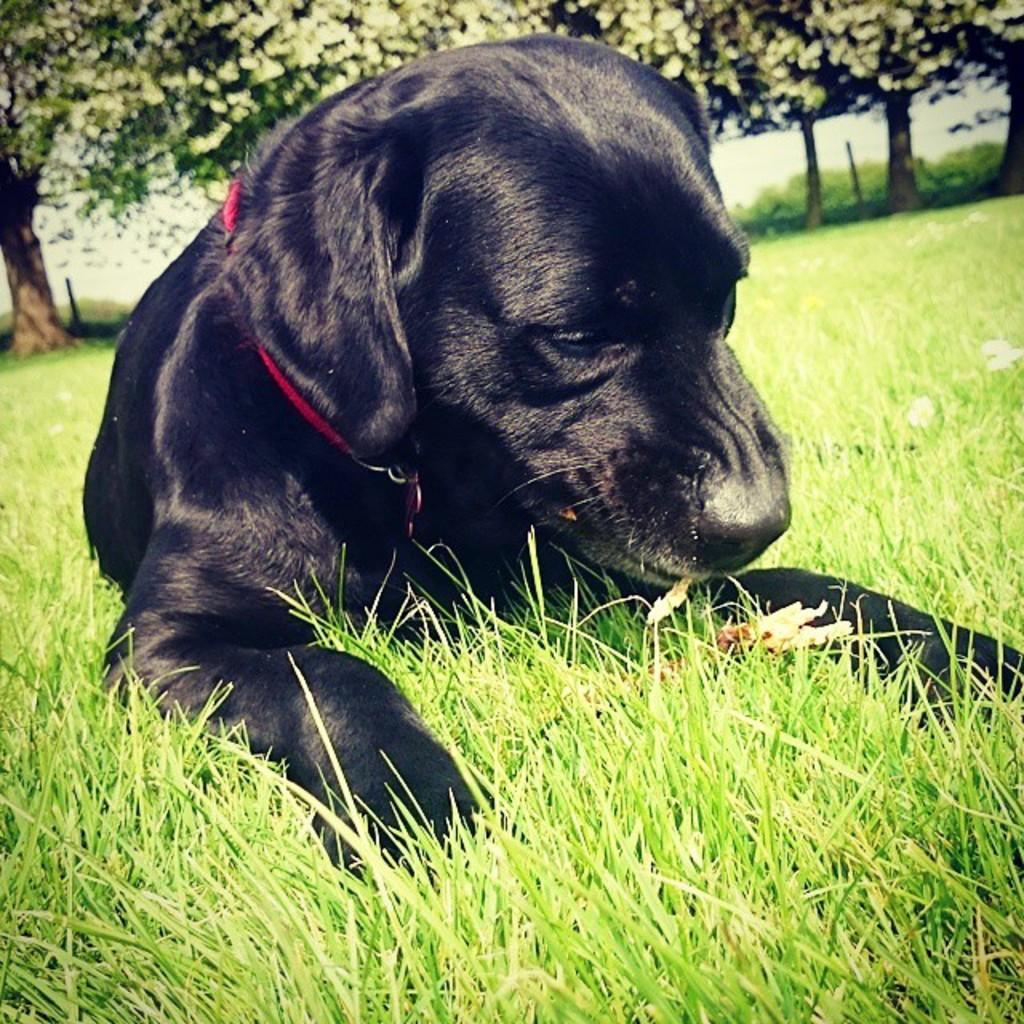What type of animal is in the image? There is a black dog in the image. What color is the dog's leash? The dog has a red leash. How is the leash positioned in the image? The leash is resting on the ground. What type of vegetation is visible in the image? There is grass visible in the image. What can be seen in the background of the image? There are trees in the background of the image. Can you tell me how many jellyfish are swimming in the background of the image? There are no jellyfish present in the image; it features a black dog with a red leash, grass, and trees in the background. 